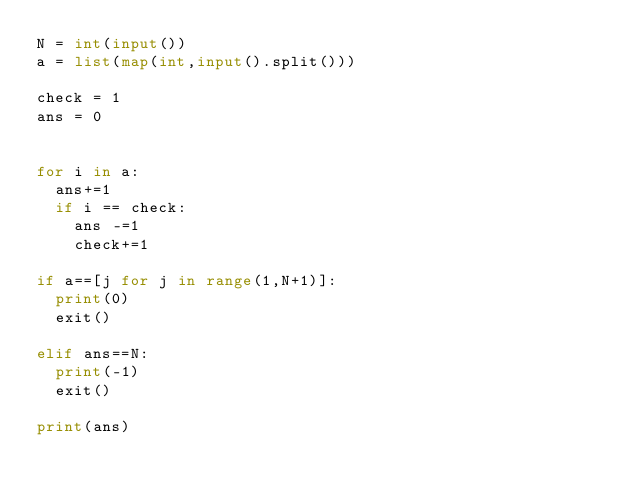<code> <loc_0><loc_0><loc_500><loc_500><_Python_>N = int(input())
a = list(map(int,input().split()))

check = 1
ans = 0


for i in a:
  ans+=1
  if i == check:
    ans -=1
    check+=1
    
if a==[j for j in range(1,N+1)]:
  print(0)
  exit()
  
elif ans==N:
  print(-1)
  exit()

print(ans)
  
  

</code> 